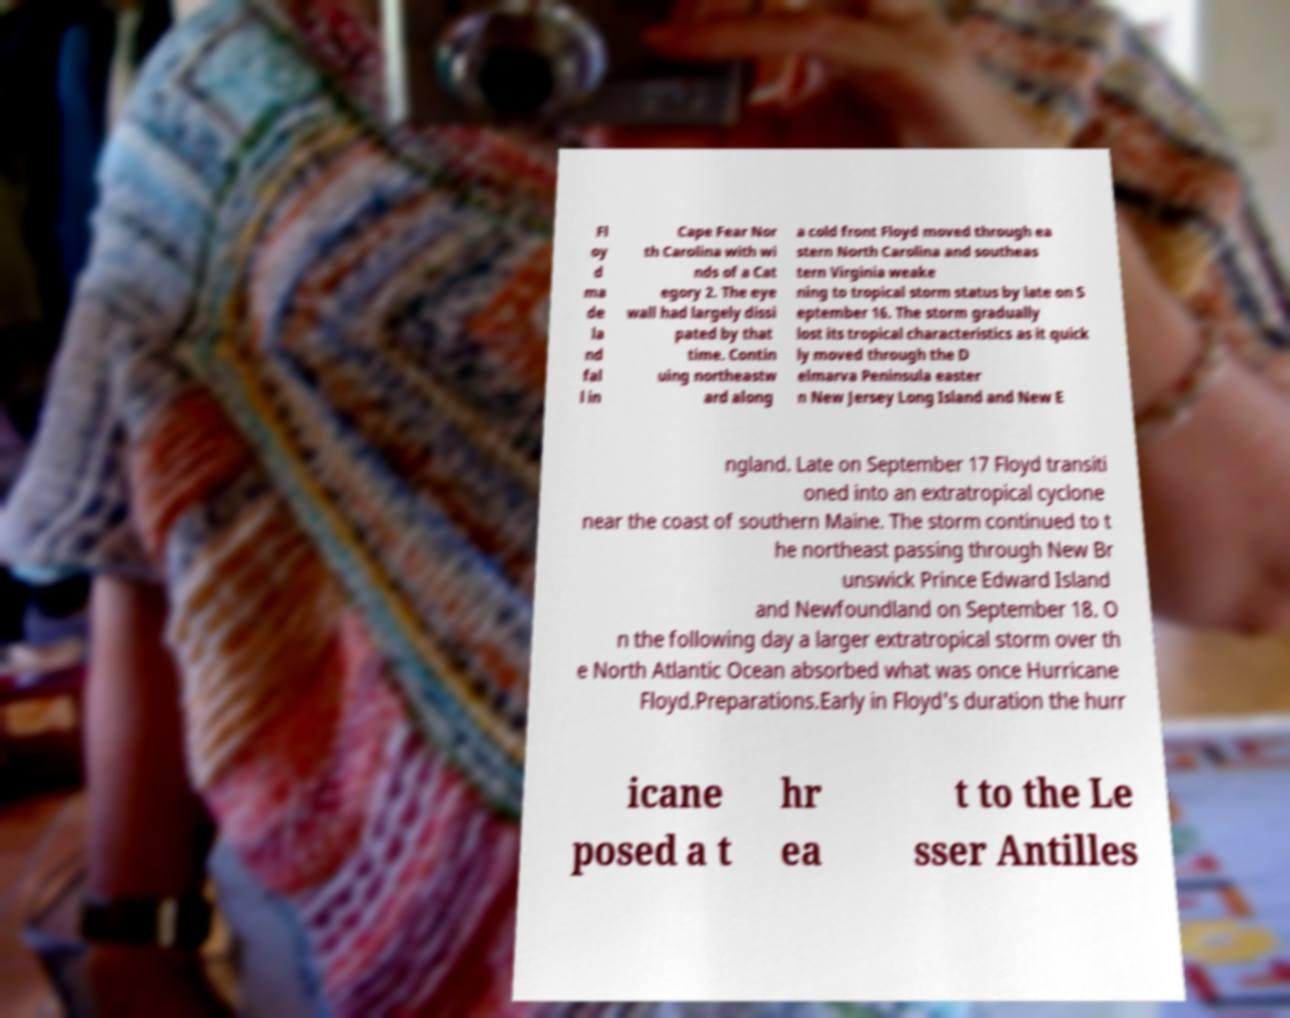What messages or text are displayed in this image? I need them in a readable, typed format. Fl oy d ma de la nd fal l in Cape Fear Nor th Carolina with wi nds of a Cat egory 2. The eye wall had largely dissi pated by that time. Contin uing northeastw ard along a cold front Floyd moved through ea stern North Carolina and southeas tern Virginia weake ning to tropical storm status by late on S eptember 16. The storm gradually lost its tropical characteristics as it quick ly moved through the D elmarva Peninsula easter n New Jersey Long Island and New E ngland. Late on September 17 Floyd transiti oned into an extratropical cyclone near the coast of southern Maine. The storm continued to t he northeast passing through New Br unswick Prince Edward Island and Newfoundland on September 18. O n the following day a larger extratropical storm over th e North Atlantic Ocean absorbed what was once Hurricane Floyd.Preparations.Early in Floyd's duration the hurr icane posed a t hr ea t to the Le sser Antilles 